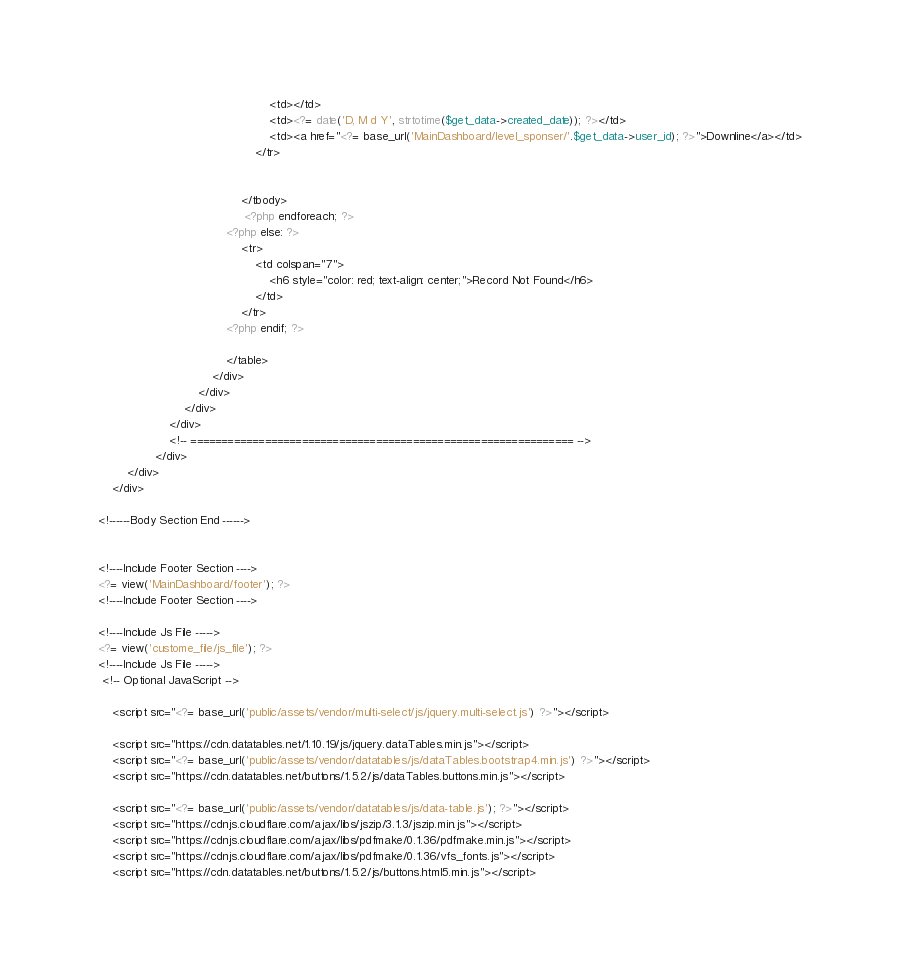<code> <loc_0><loc_0><loc_500><loc_500><_PHP_>                                                <td></td>
                                                <td><?= date('D, M d Y', strtotime($get_data->created_date)); ?></td>
                                                <td><a href="<?= base_url('MainDashboard/level_sponser/'.$get_data->user_id); ?>">Downline</a></td>
                                            </tr>
                                            
                                          
                                        </tbody>
                                         <?php endforeach; ?>
                                    <?php else: ?>
                                        <tr>
                                            <td colspan="7">
                                                <h6 style="color: red; text-align: center;">Record Not Found</h6>
                                            </td>
                                        </tr>
                                    <?php endif; ?> 
                                        
                                    </table>
                                </div>
                            </div>
                        </div>
                    </div>
                    <!-- ============================================================== -->
                </div>
        </div>
    </div>

<!------Body Section End ------>


<!----Include Footer Section ---->
<?= view('MainDashboard/footer'); ?> 
<!----Include Footer Section ---->

<!----Include Js File ----->
<?= view('custome_file/js_file'); ?>    
<!----Include Js File ----->
 <!-- Optional JavaScript -->
    
    <script src="<?= base_url('public/assets/vendor/multi-select/js/jquery.multi-select.js') ?>"></script>
   
    <script src="https://cdn.datatables.net/1.10.19/js/jquery.dataTables.min.js"></script>
    <script src="<?= base_url('public/assets/vendor/datatables/js/dataTables.bootstrap4.min.js') ?>"></script>
    <script src="https://cdn.datatables.net/buttons/1.5.2/js/dataTables.buttons.min.js"></script>
   
    <script src="<?= base_url('public/assets/vendor/datatables/js/data-table.js'); ?>"></script>
    <script src="https://cdnjs.cloudflare.com/ajax/libs/jszip/3.1.3/jszip.min.js"></script>
    <script src="https://cdnjs.cloudflare.com/ajax/libs/pdfmake/0.1.36/pdfmake.min.js"></script>
    <script src="https://cdnjs.cloudflare.com/ajax/libs/pdfmake/0.1.36/vfs_fonts.js"></script>
    <script src="https://cdn.datatables.net/buttons/1.5.2/js/buttons.html5.min.js"></script></code> 